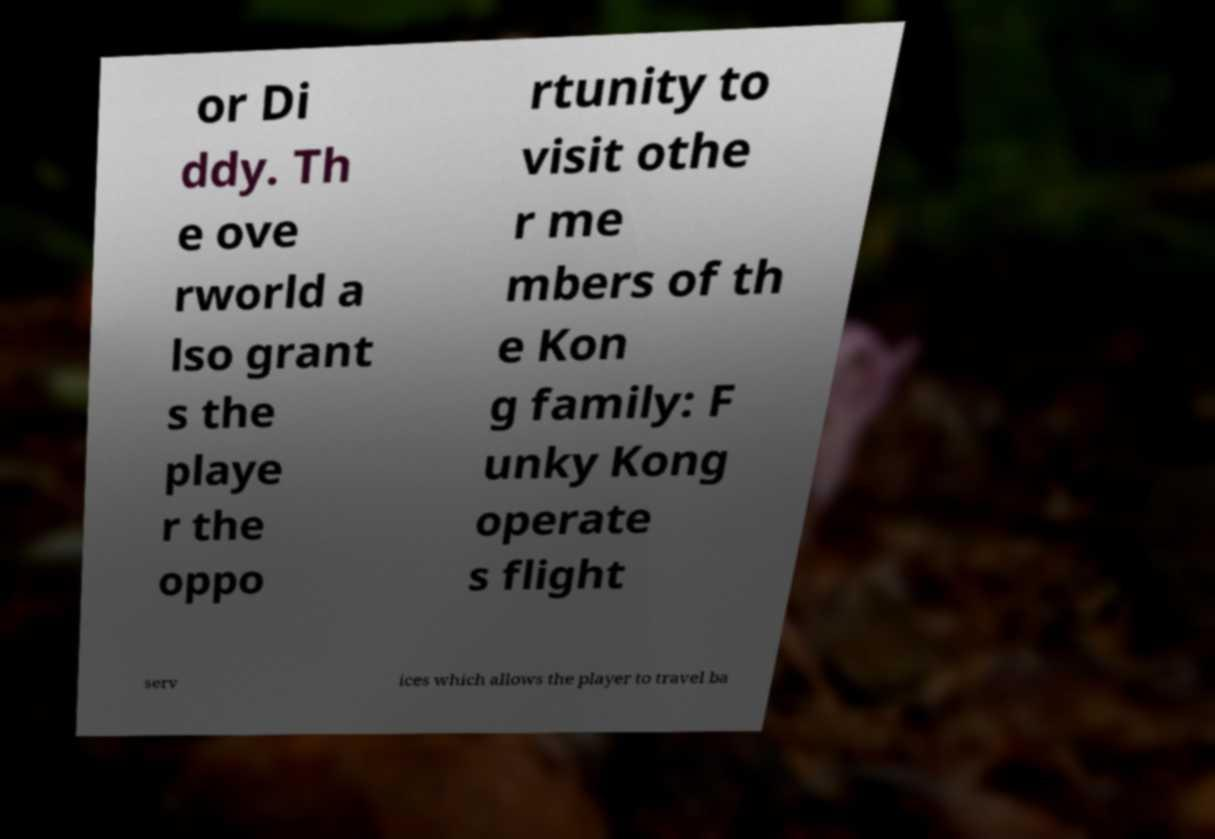Please read and relay the text visible in this image. What does it say? or Di ddy. Th e ove rworld a lso grant s the playe r the oppo rtunity to visit othe r me mbers of th e Kon g family: F unky Kong operate s flight serv ices which allows the player to travel ba 